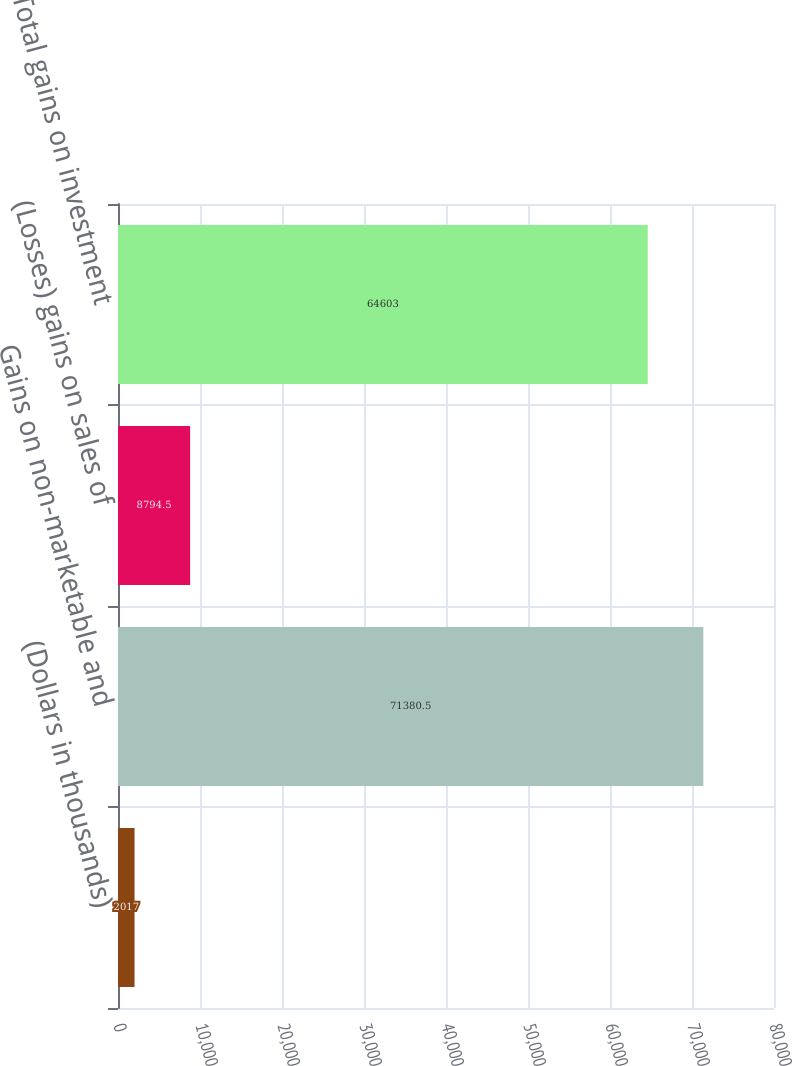<chart> <loc_0><loc_0><loc_500><loc_500><bar_chart><fcel>(Dollars in thousands)<fcel>Gains on non-marketable and<fcel>(Losses) gains on sales of<fcel>Total gains on investment<nl><fcel>2017<fcel>71380.5<fcel>8794.5<fcel>64603<nl></chart> 